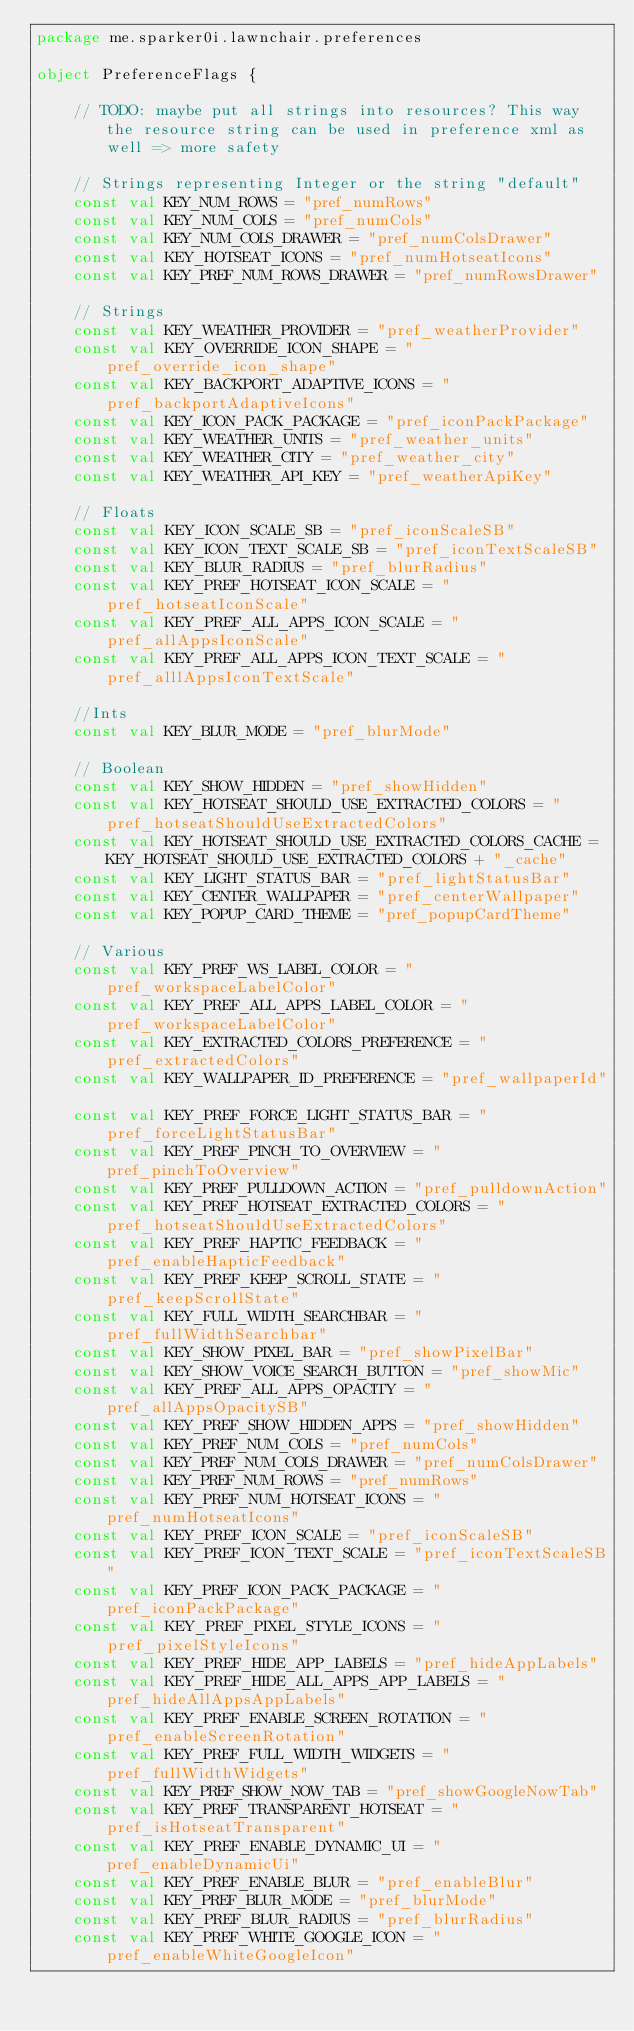Convert code to text. <code><loc_0><loc_0><loc_500><loc_500><_Kotlin_>package me.sparker0i.lawnchair.preferences

object PreferenceFlags {

    // TODO: maybe put all strings into resources? This way the resource string can be used in preference xml as well => more safety

    // Strings representing Integer or the string "default"
    const val KEY_NUM_ROWS = "pref_numRows"
    const val KEY_NUM_COLS = "pref_numCols"
    const val KEY_NUM_COLS_DRAWER = "pref_numColsDrawer"
    const val KEY_HOTSEAT_ICONS = "pref_numHotseatIcons"
    const val KEY_PREF_NUM_ROWS_DRAWER = "pref_numRowsDrawer"

    // Strings
    const val KEY_WEATHER_PROVIDER = "pref_weatherProvider"
    const val KEY_OVERRIDE_ICON_SHAPE = "pref_override_icon_shape"
    const val KEY_BACKPORT_ADAPTIVE_ICONS = "pref_backportAdaptiveIcons"
    const val KEY_ICON_PACK_PACKAGE = "pref_iconPackPackage"
    const val KEY_WEATHER_UNITS = "pref_weather_units"
    const val KEY_WEATHER_CITY = "pref_weather_city"
    const val KEY_WEATHER_API_KEY = "pref_weatherApiKey"

    // Floats
    const val KEY_ICON_SCALE_SB = "pref_iconScaleSB"
    const val KEY_ICON_TEXT_SCALE_SB = "pref_iconTextScaleSB"
    const val KEY_BLUR_RADIUS = "pref_blurRadius"
    const val KEY_PREF_HOTSEAT_ICON_SCALE = "pref_hotseatIconScale"
    const val KEY_PREF_ALL_APPS_ICON_SCALE = "pref_allAppsIconScale"
    const val KEY_PREF_ALL_APPS_ICON_TEXT_SCALE = "pref_alllAppsIconTextScale"

    //Ints
    const val KEY_BLUR_MODE = "pref_blurMode"

    // Boolean
    const val KEY_SHOW_HIDDEN = "pref_showHidden"
    const val KEY_HOTSEAT_SHOULD_USE_EXTRACTED_COLORS = "pref_hotseatShouldUseExtractedColors"
    const val KEY_HOTSEAT_SHOULD_USE_EXTRACTED_COLORS_CACHE = KEY_HOTSEAT_SHOULD_USE_EXTRACTED_COLORS + "_cache"
    const val KEY_LIGHT_STATUS_BAR = "pref_lightStatusBar"
    const val KEY_CENTER_WALLPAPER = "pref_centerWallpaper"
    const val KEY_POPUP_CARD_THEME = "pref_popupCardTheme"

    // Various
    const val KEY_PREF_WS_LABEL_COLOR = "pref_workspaceLabelColor"
    const val KEY_PREF_ALL_APPS_LABEL_COLOR = "pref_workspaceLabelColor"
    const val KEY_EXTRACTED_COLORS_PREFERENCE = "pref_extractedColors"
    const val KEY_WALLPAPER_ID_PREFERENCE = "pref_wallpaperId"

    const val KEY_PREF_FORCE_LIGHT_STATUS_BAR = "pref_forceLightStatusBar"
    const val KEY_PREF_PINCH_TO_OVERVIEW = "pref_pinchToOverview"
    const val KEY_PREF_PULLDOWN_ACTION = "pref_pulldownAction"
    const val KEY_PREF_HOTSEAT_EXTRACTED_COLORS = "pref_hotseatShouldUseExtractedColors"
    const val KEY_PREF_HAPTIC_FEEDBACK = "pref_enableHapticFeedback"
    const val KEY_PREF_KEEP_SCROLL_STATE = "pref_keepScrollState"
    const val KEY_FULL_WIDTH_SEARCHBAR = "pref_fullWidthSearchbar"
    const val KEY_SHOW_PIXEL_BAR = "pref_showPixelBar"
    const val KEY_SHOW_VOICE_SEARCH_BUTTON = "pref_showMic"
    const val KEY_PREF_ALL_APPS_OPACITY = "pref_allAppsOpacitySB"
    const val KEY_PREF_SHOW_HIDDEN_APPS = "pref_showHidden"
    const val KEY_PREF_NUM_COLS = "pref_numCols"
    const val KEY_PREF_NUM_COLS_DRAWER = "pref_numColsDrawer"
    const val KEY_PREF_NUM_ROWS = "pref_numRows"
    const val KEY_PREF_NUM_HOTSEAT_ICONS = "pref_numHotseatIcons"
    const val KEY_PREF_ICON_SCALE = "pref_iconScaleSB"
    const val KEY_PREF_ICON_TEXT_SCALE = "pref_iconTextScaleSB"
    const val KEY_PREF_ICON_PACK_PACKAGE = "pref_iconPackPackage"
    const val KEY_PREF_PIXEL_STYLE_ICONS = "pref_pixelStyleIcons"
    const val KEY_PREF_HIDE_APP_LABELS = "pref_hideAppLabels"
    const val KEY_PREF_HIDE_ALL_APPS_APP_LABELS = "pref_hideAllAppsAppLabels"
    const val KEY_PREF_ENABLE_SCREEN_ROTATION = "pref_enableScreenRotation"
    const val KEY_PREF_FULL_WIDTH_WIDGETS = "pref_fullWidthWidgets"
    const val KEY_PREF_SHOW_NOW_TAB = "pref_showGoogleNowTab"
    const val KEY_PREF_TRANSPARENT_HOTSEAT = "pref_isHotseatTransparent"
    const val KEY_PREF_ENABLE_DYNAMIC_UI = "pref_enableDynamicUi"
    const val KEY_PREF_ENABLE_BLUR = "pref_enableBlur"
    const val KEY_PREF_BLUR_MODE = "pref_blurMode"
    const val KEY_PREF_BLUR_RADIUS = "pref_blurRadius"
    const val KEY_PREF_WHITE_GOOGLE_ICON = "pref_enableWhiteGoogleIcon"</code> 